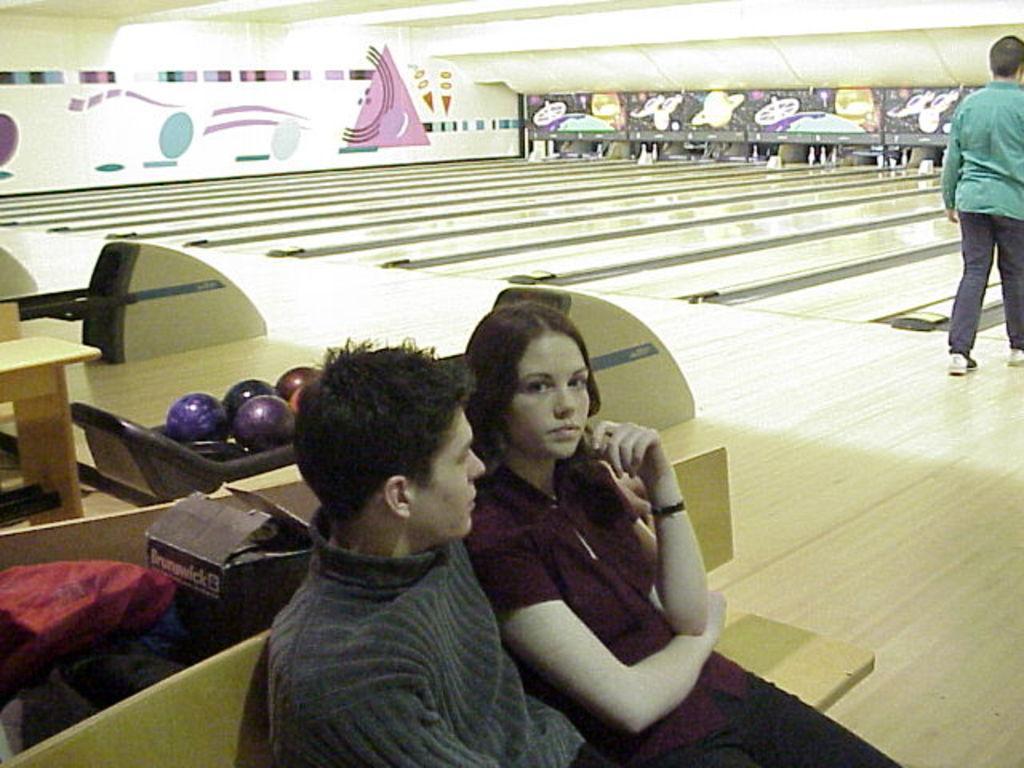In one or two sentences, can you explain what this image depicts? In this image we can see a man and a woman sitting on a bench at the bottom of the image. At the top of the image we can see bowling area and a person stood near it. 